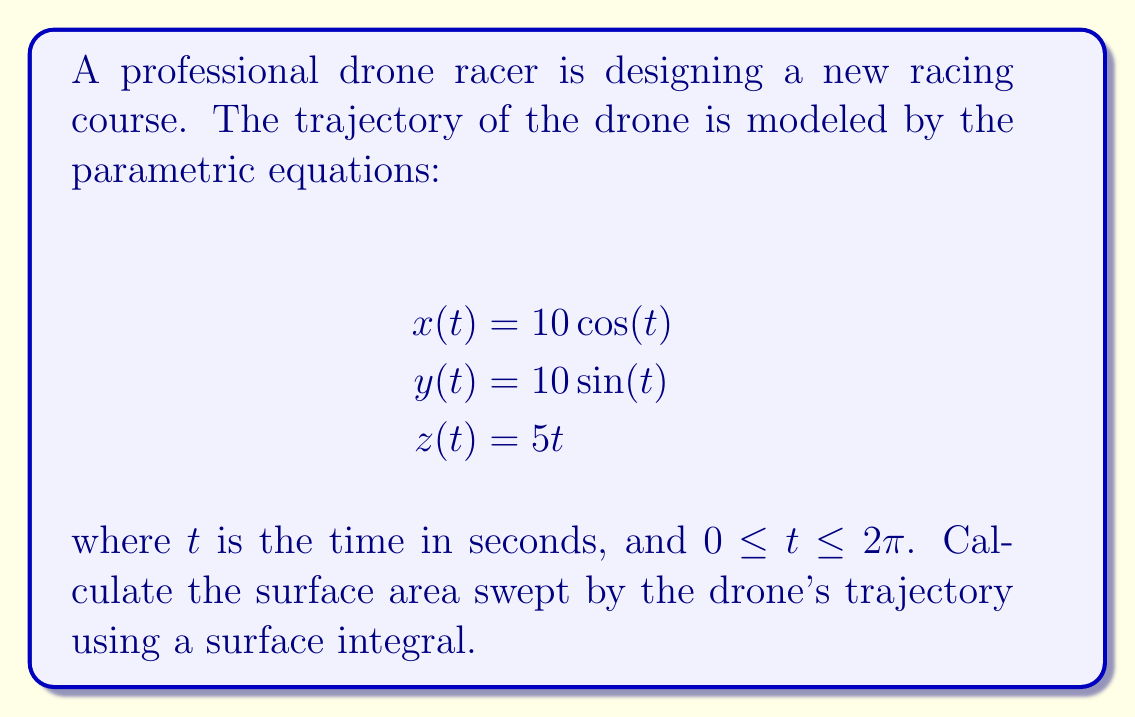Help me with this question. To calculate the surface area swept by the drone's trajectory, we need to follow these steps:

1) First, we need to find the parametric surface that represents the area swept by the trajectory. This surface can be described as:

   $$\mathbf{r}(t,v) = \langle 10\cos(t), 10\sin(t), 5t \rangle + v\mathbf{n}(t)$$

   where $\mathbf{n}(t)$ is the unit normal vector to the curve at time $t$, and $0 \leq v \leq \epsilon$ for some small $\epsilon$.

2) The unit tangent vector $\mathbf{T}(t)$ is:

   $$\mathbf{T}(t) = \frac{\langle -10\sin(t), 10\cos(t), 5 \rangle}{\sqrt{100\sin^2(t) + 100\cos^2(t) + 25}}$$

3) The unit normal vector $\mathbf{n}(t)$ can be found by normalizing $\mathbf{T}'(t)$:

   $$\mathbf{n}(t) = \frac{\langle -10\cos(t), -10\sin(t), 0 \rangle}{\sqrt{100\cos^2(t) + 100\sin^2(t)}} = \langle -\cos(t), -\sin(t), 0 \rangle$$

4) Now, we can compute the surface area using the surface integral:

   $$A = \int_0^{2\pi} \int_0^{\epsilon} |\mathbf{r}_t \times \mathbf{r}_v| dv dt$$

5) Calculate $\mathbf{r}_t$ and $\mathbf{r}_v$:

   $$\mathbf{r}_t = \langle -10\sin(t), 10\cos(t), 5 \rangle + v\langle \sin(t), -\cos(t), 0 \rangle$$
   $$\mathbf{r}_v = \langle -\cos(t), -\sin(t), 0 \rangle$$

6) Compute $\mathbf{r}_t \times \mathbf{r}_v$:

   $$\mathbf{r}_t \times \mathbf{r}_v = \langle 5\sin(t), -5\cos(t), 10 \rangle$$

7) Calculate $|\mathbf{r}_t \times \mathbf{r}_v|$:

   $$|\mathbf{r}_t \times \mathbf{r}_v| = \sqrt{25\sin^2(t) + 25\cos^2(t) + 100} = \sqrt{125} = 5\sqrt{5}$$

8) Now, we can evaluate the surface integral:

   $$A = \int_0^{2\pi} \int_0^{\epsilon} 5\sqrt{5} dv dt = 5\sqrt{5} \epsilon \int_0^{2\pi} dt = 10\pi\sqrt{5} \epsilon$$

As $\epsilon$ approaches 0, this gives us the arc length of the curve multiplied by $2\pi$, which is the circumference of the circular cross-section of the helical surface.
Answer: $10\pi\sqrt{5} \epsilon$ 